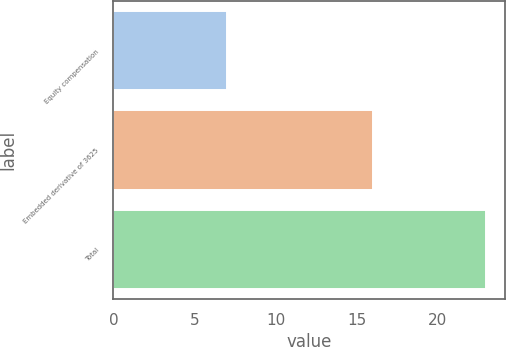Convert chart to OTSL. <chart><loc_0><loc_0><loc_500><loc_500><bar_chart><fcel>Equity compensation<fcel>Embedded derivative of 3625<fcel>Total<nl><fcel>7<fcel>16<fcel>23<nl></chart> 